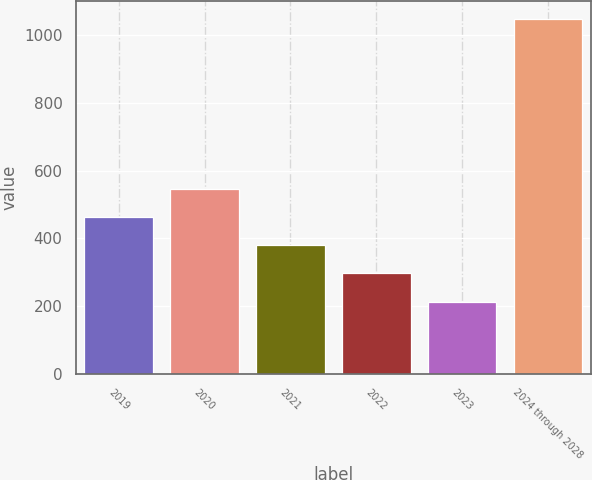<chart> <loc_0><loc_0><loc_500><loc_500><bar_chart><fcel>2019<fcel>2020<fcel>2021<fcel>2022<fcel>2023<fcel>2024 through 2028<nl><fcel>463.5<fcel>547<fcel>380<fcel>296.5<fcel>213<fcel>1048<nl></chart> 